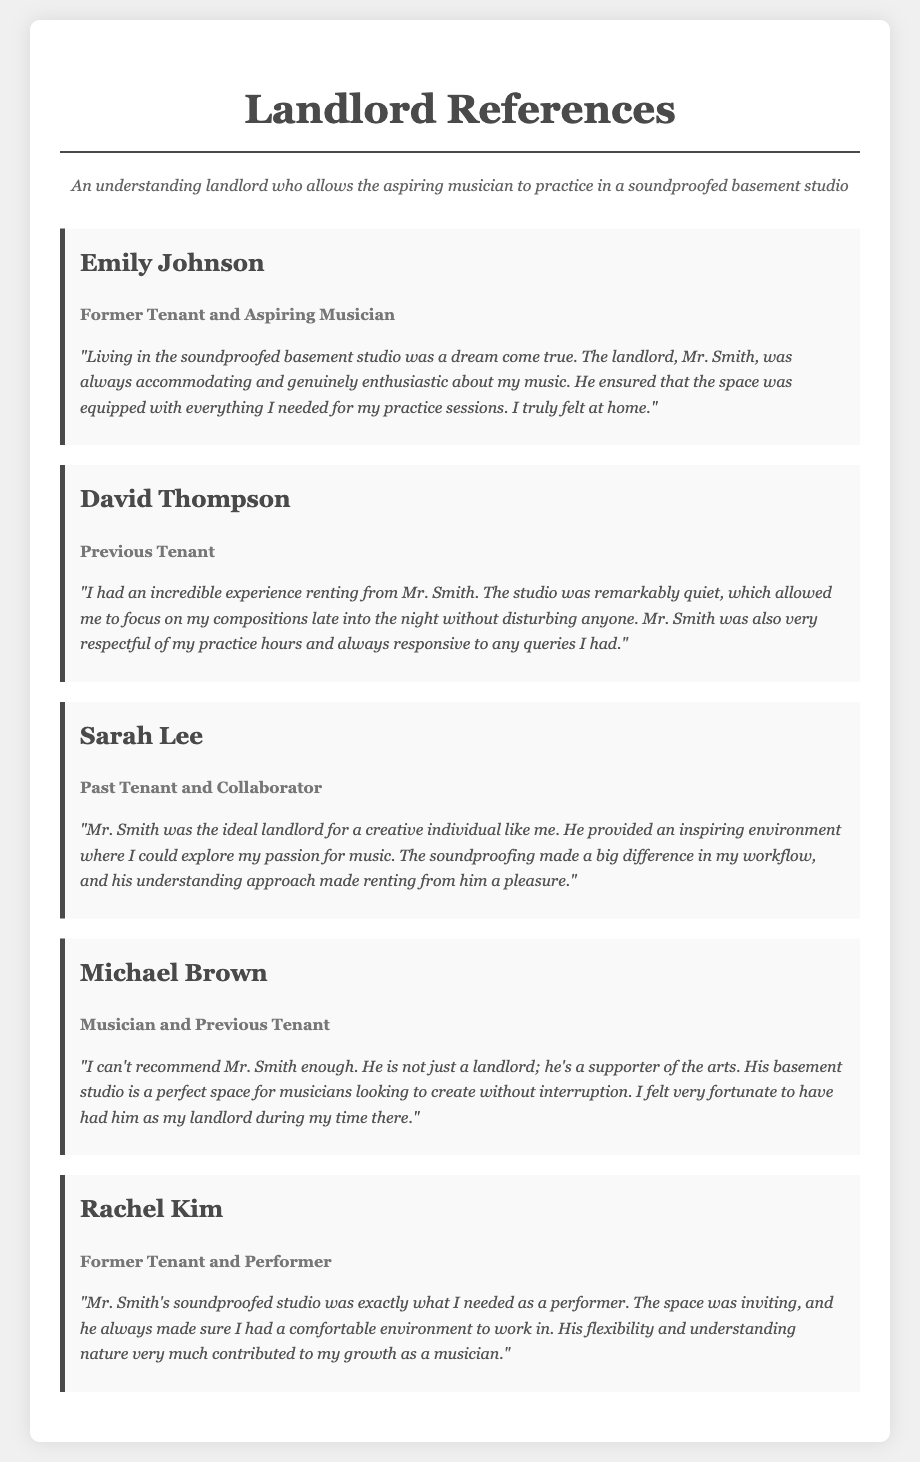What is the name of the first reference? The first reference listed is Emily Johnson.
Answer: Emily Johnson What is the relationship of Michael Brown to Mr. Smith? Michael Brown is identified as a musician and previous tenant.
Answer: Musician and Previous Tenant What did Sarah Lee appreciate about Mr. Smith? Sarah Lee appreciated the inspiring environment provided for her music practice.
Answer: Inspiring environment How many references are listed in total? There are five references included in the document.
Answer: Five Which reference specifically mentions flexibility and understanding? Rachel Kim specifically mentions Mr. Smith's flexibility and understanding nature.
Answer: Rachel Kim What is the key feature of the studio mentioned by David Thompson? David Thompson mentions that the studio was remarkably quiet.
Answer: Remarkably quiet What type of tenant is Emily Johnson described as? Emily Johnson is described as a former tenant and aspiring musician.
Answer: Former Tenant and Aspiring Musician Who felt fortunate to have Mr. Smith as their landlord? Michael Brown expressed that he felt fortunate to have Mr. Smith as a landlord.
Answer: Michael Brown 